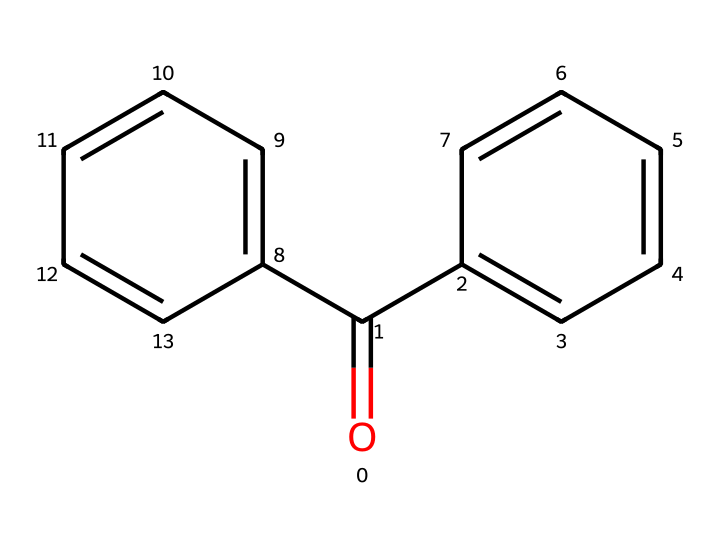How many carbon atoms are in benzophenone? The SMILES representation shows that there are two phenyl rings (c1ccccc1) and one carbonyl group (O=C). Each phenyl ring contributes six carbon atoms, and there is one carbon in the carbonyl, totaling to 12 carbon atoms.
Answer: 13 What is the functional group present in benzophenone? The structure shows a carbonyl group (C=O) directly attached to two phenyl groups, which is characteristic of ketones. The presence of this carbonyl group identifies benzophenone as a ketone.
Answer: carbonyl How many hydrogen atoms are attached to the phenyl rings in benzophenone? Each phenyl ring can host 5 hydrogen atoms due to the aromatic structure (C6H5). Since there are two phenyl rings attached to the carbonyl carbon, we have 10 hydrogen atoms in total.
Answer: 10 What is the molecular formula of benzophenone? The molecule has 13 carbon atoms, 10 hydrogen atoms, and 1 oxygen atom. This can be represented as C13H10O, which is confirmed by counting the atoms from the SMILES string.
Answer: C13H10O How does the structure of benzophenone affect its use in UV-curing inks? The presence of the carbonyl group makes benzophenone an effective photoinitiator, as it can absorb UV light and produce reactive radicals that initiate polymerization, which is crucial in UV-curing processes.
Answer: photoinitiator What type of isomerism is exhibited by benzophenone? Benzophenone does not exhibit any significant geometric or structural isomerism by itself due to its symmetrical structure; it is categorized primarily as a ketone, which indicates it does not possess an asymmetric center for enantiomerism.
Answer: none 